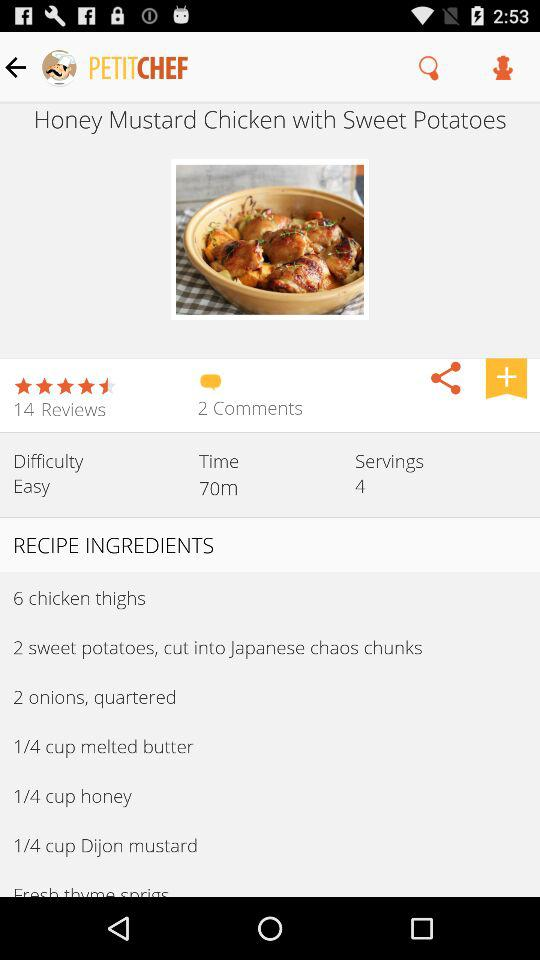How much time is taken to prepare the "Honey Mustard Chicken with Sweet Potatoes"? The time taken to prepare the "Honey Mustard Chicken with Sweet Potatoes" is 70 minutes. 